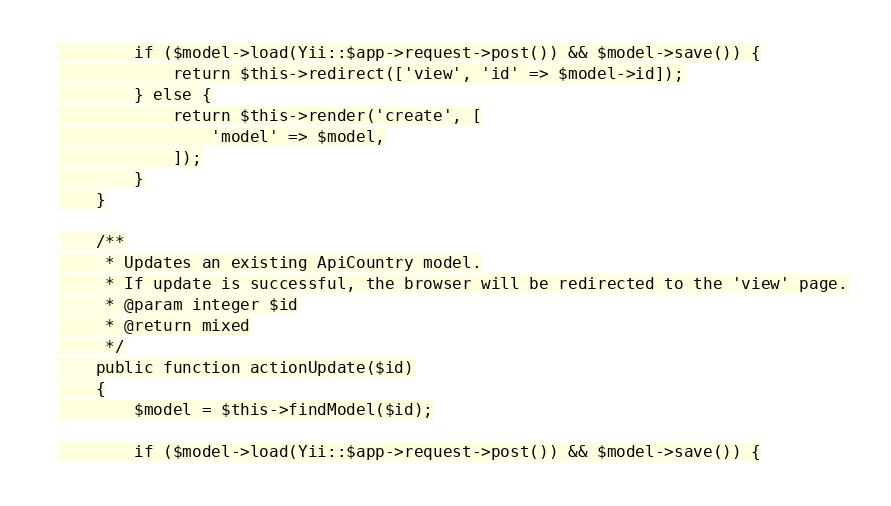<code> <loc_0><loc_0><loc_500><loc_500><_PHP_>
        if ($model->load(Yii::$app->request->post()) && $model->save()) {
            return $this->redirect(['view', 'id' => $model->id]);
        } else {
            return $this->render('create', [
                'model' => $model,
            ]);
        }
    }

    /**
     * Updates an existing ApiCountry model.
     * If update is successful, the browser will be redirected to the 'view' page.
     * @param integer $id
     * @return mixed
     */
    public function actionUpdate($id)
    {
        $model = $this->findModel($id);

        if ($model->load(Yii::$app->request->post()) && $model->save()) {</code> 